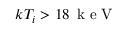<formula> <loc_0><loc_0><loc_500><loc_500>k T _ { i } > 1 8 \, k e V</formula> 